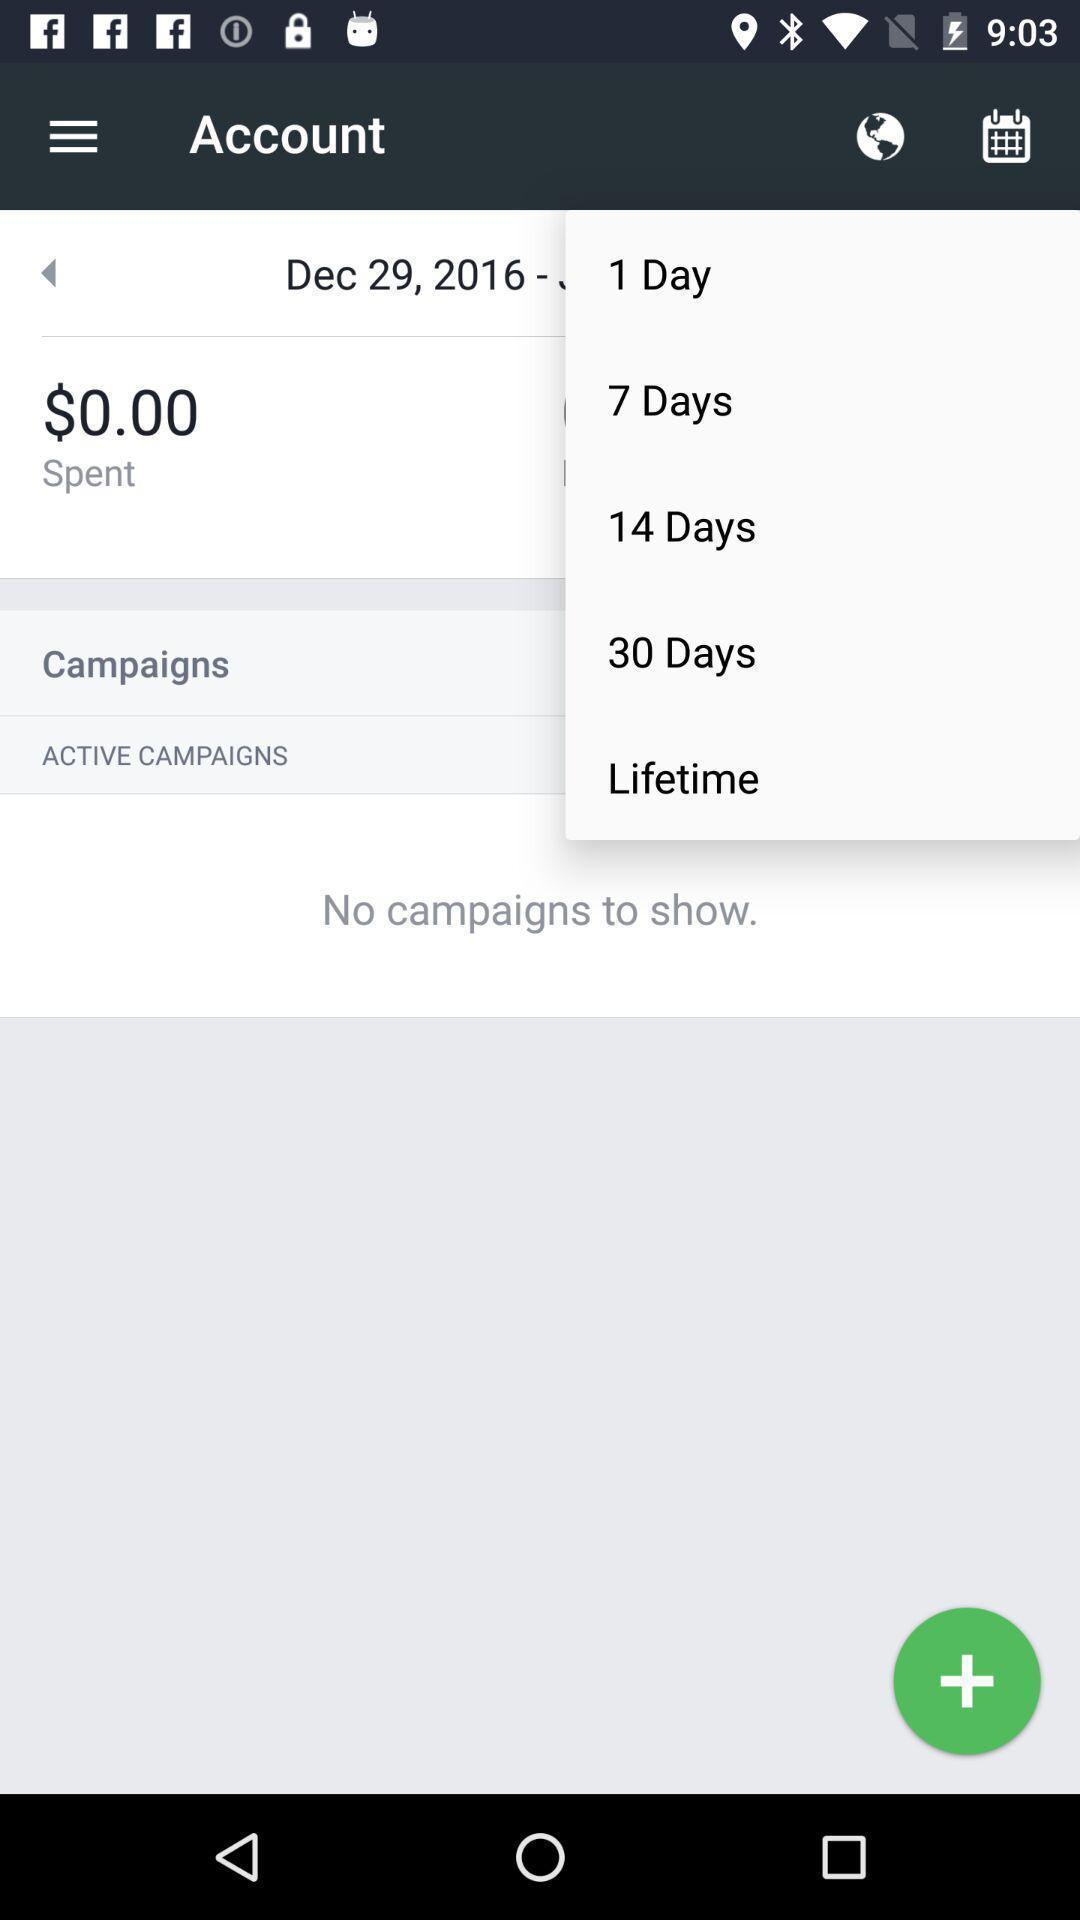Summarize the main components in this picture. Widget showing number of days to select. 